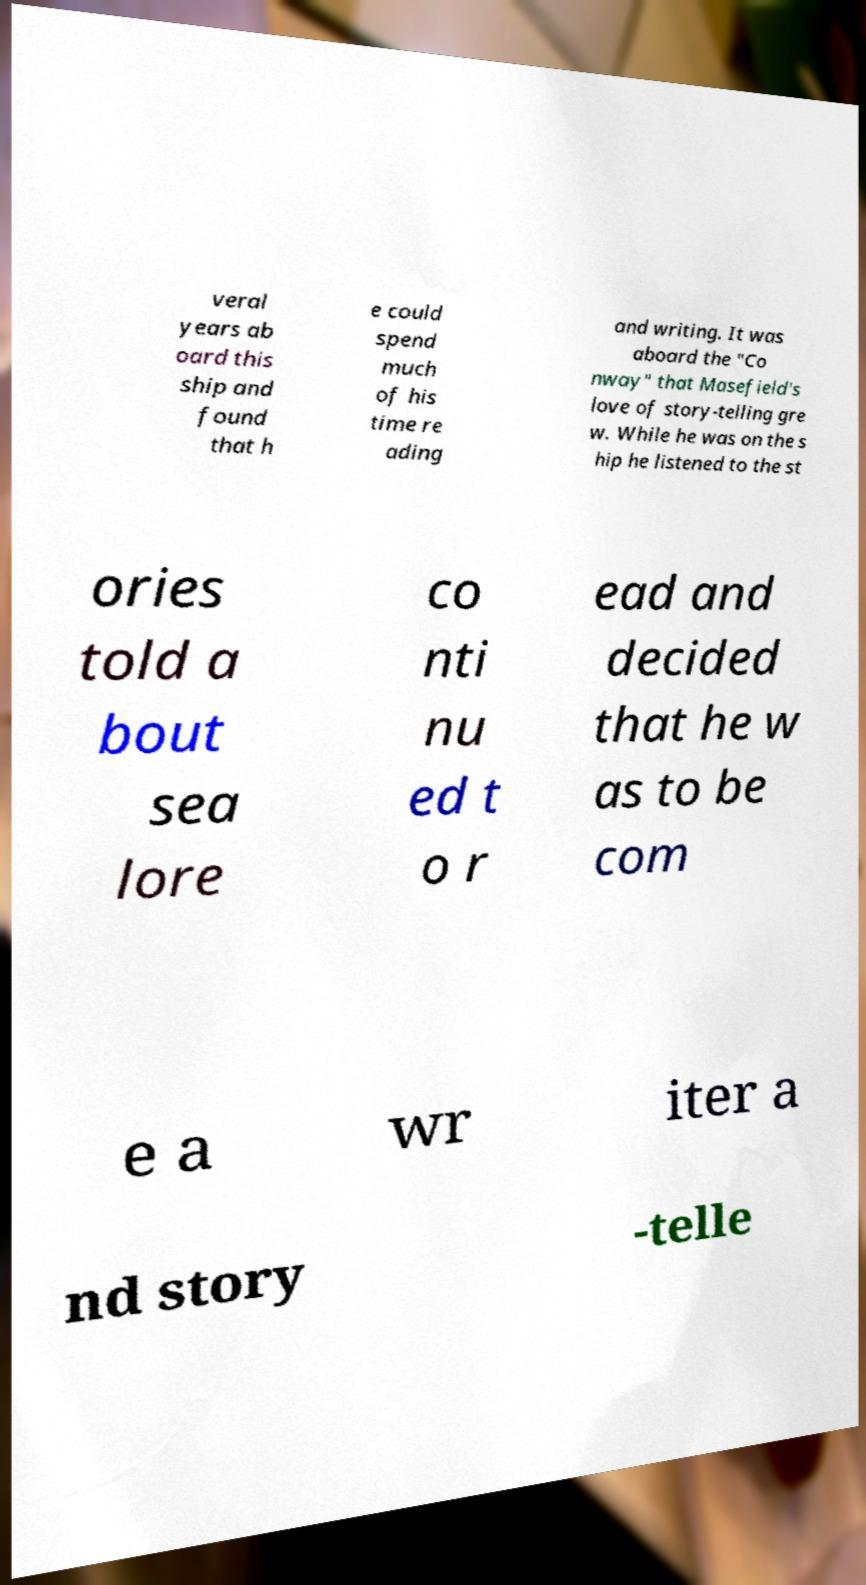For documentation purposes, I need the text within this image transcribed. Could you provide that? veral years ab oard this ship and found that h e could spend much of his time re ading and writing. It was aboard the "Co nway" that Masefield's love of story-telling gre w. While he was on the s hip he listened to the st ories told a bout sea lore co nti nu ed t o r ead and decided that he w as to be com e a wr iter a nd story -telle 